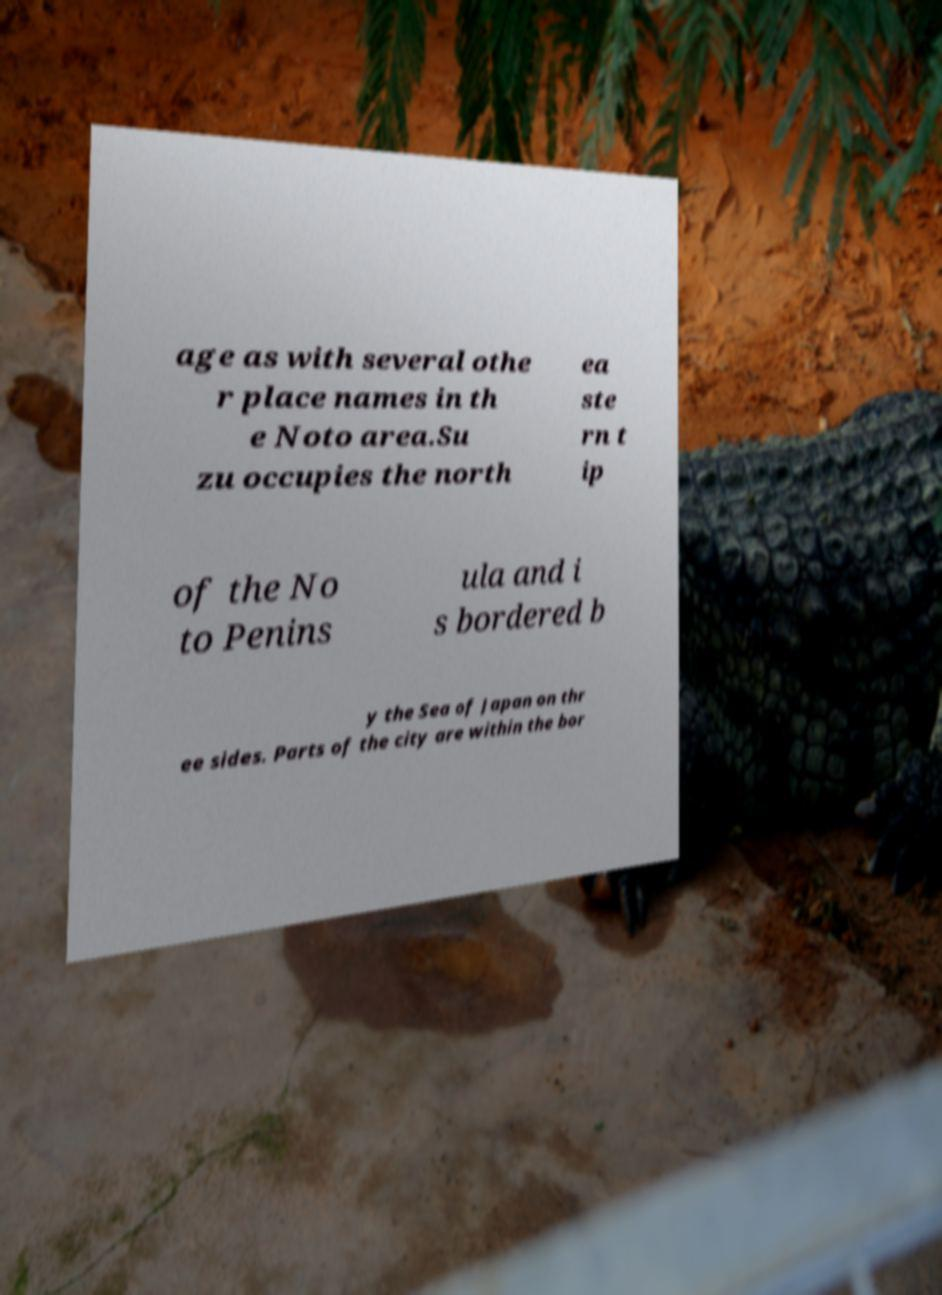Can you read and provide the text displayed in the image?This photo seems to have some interesting text. Can you extract and type it out for me? age as with several othe r place names in th e Noto area.Su zu occupies the north ea ste rn t ip of the No to Penins ula and i s bordered b y the Sea of Japan on thr ee sides. Parts of the city are within the bor 